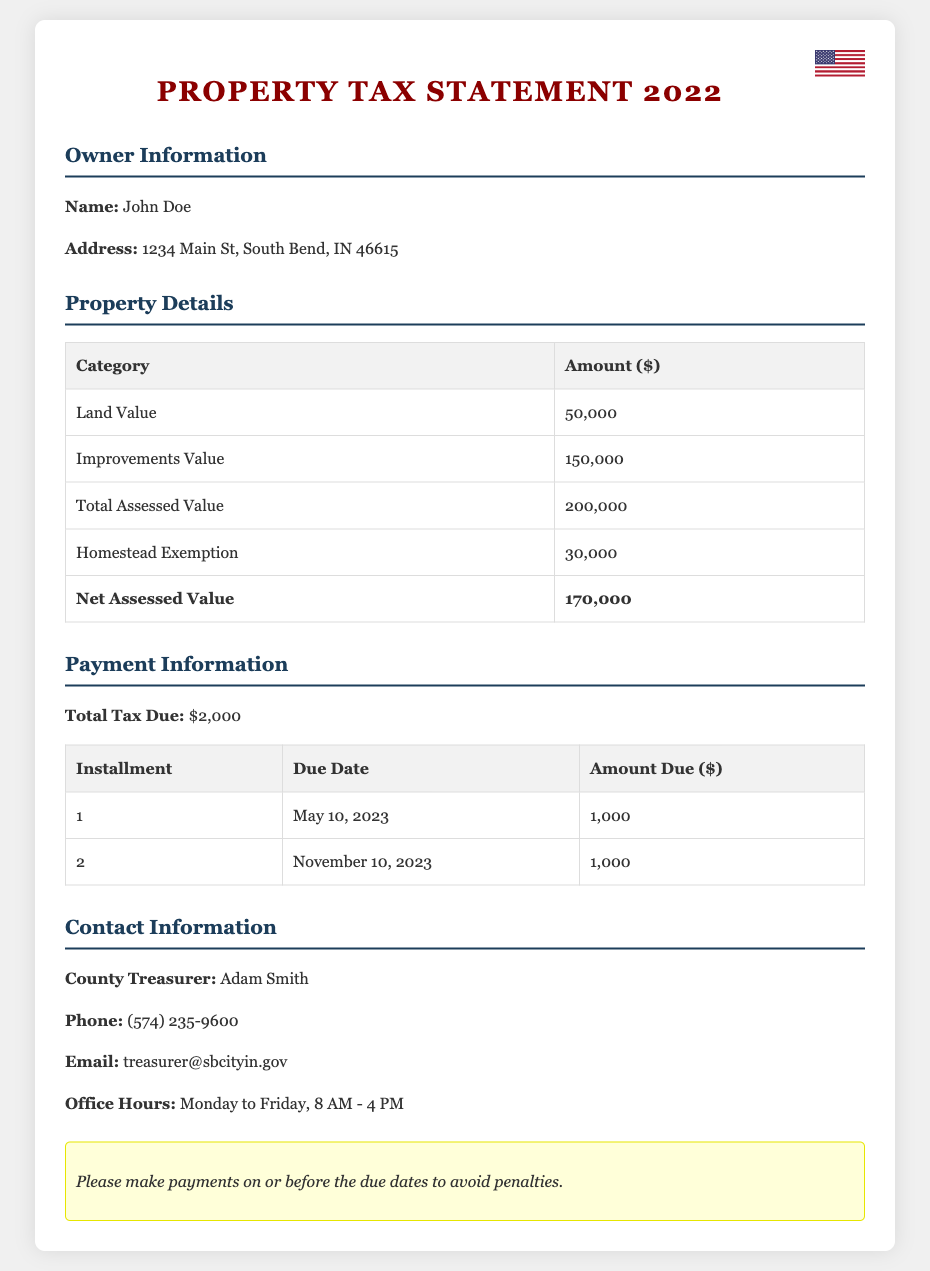What is the owner's name? The owner's name is listed in the owner information section of the document.
Answer: John Doe What is the total assessed value? The total assessed value can be found in the property details section of the document.
Answer: 200,000 What is the amount of the homestead exemption? The homestead exemption amount is provided in the property details section.
Answer: 30,000 What are the payment deadlines for the property tax? The payment due dates for installments are listed in the payment information section.
Answer: May 10, 2023 and November 10, 2023 What is the total tax due? The total tax due is specified in the payment information section of the document.
Answer: 2,000 What is the net assessed value? The net assessed value is calculated by subtracting the homestead exemption from the total assessed value.
Answer: 170,000 Who is the County Treasurer? The County Treasurer's name is mentioned in the contact information section.
Answer: Adam Smith What is the phone number for the County Treasurer's office? The phone number is provided in the contact information section of the document.
Answer: (574) 235-9600 What should I do to avoid penalties? The document includes notes on payment deadlines to avoid penalties.
Answer: Make payments on or before the due dates 